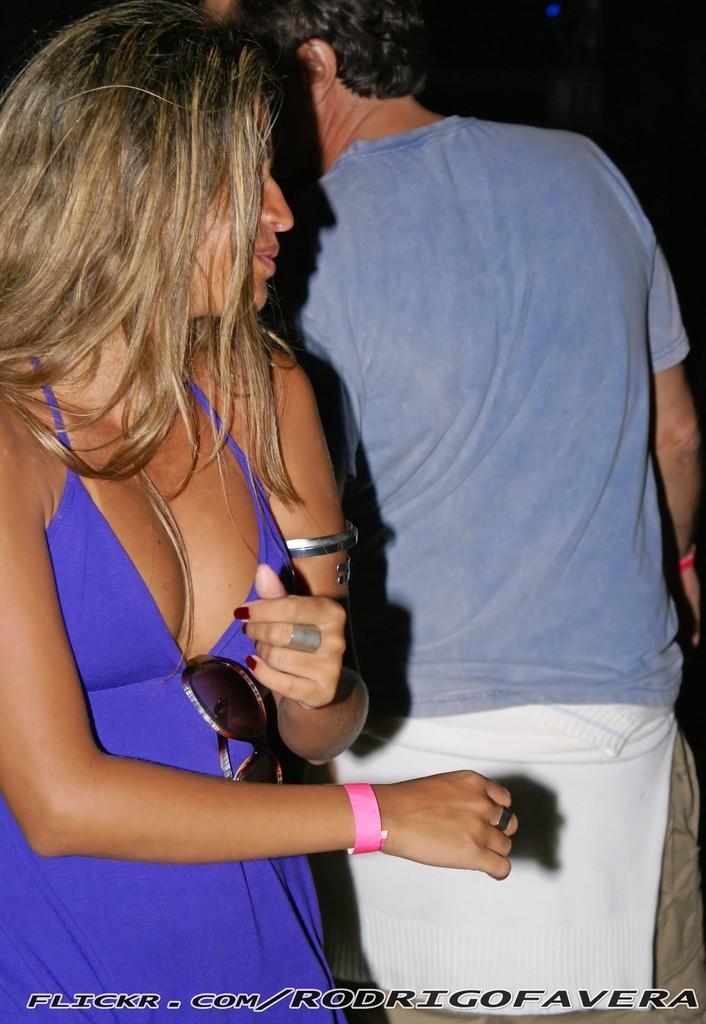Please provide a concise description of this image. In this picture we can see a man and a woman standing and in the background it is dark. 